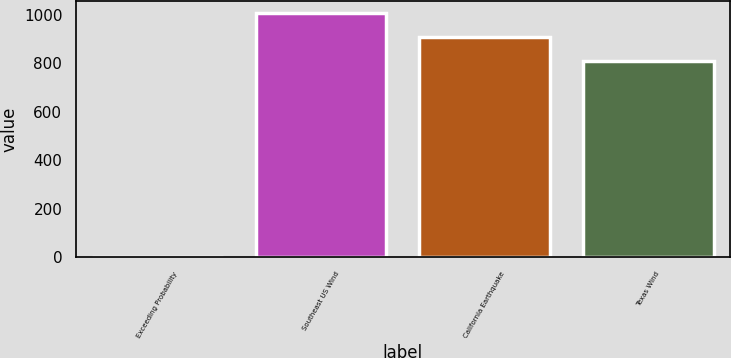Convert chart. <chart><loc_0><loc_0><loc_500><loc_500><bar_chart><fcel>Exceeding Probability<fcel>Southeast US Wind<fcel>California Earthquake<fcel>Texas Wind<nl><fcel>0.4<fcel>1006.12<fcel>907.56<fcel>809<nl></chart> 